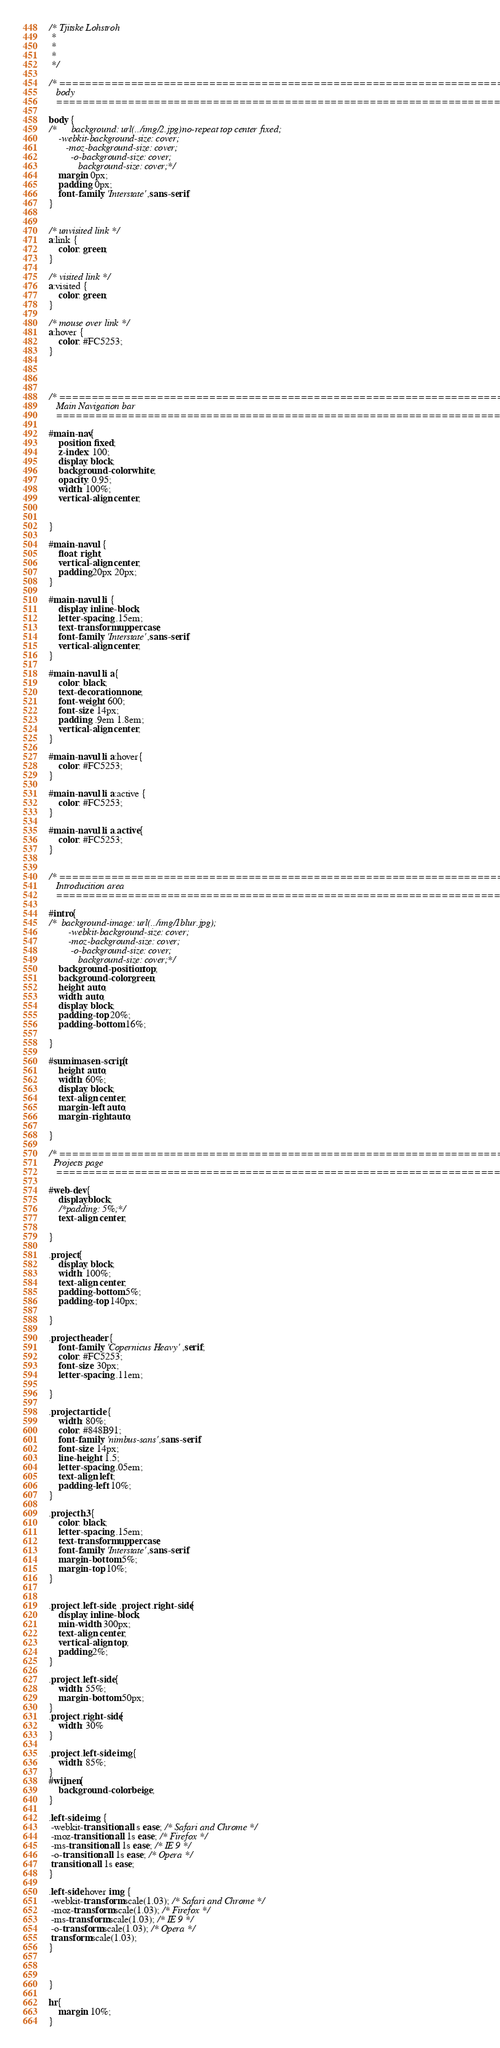Convert code to text. <code><loc_0><loc_0><loc_500><loc_500><_CSS_>/* Tjitske Lohstroh
 * 
 * 
 * 
 */

/* ==========================================================================
   body
   ========================================================================== */

body {
/*   	background: url(../img/2.jpg)no-repeat top center fixed;
	-webkit-background-size: cover;
	   -moz-background-size: cover;
	     -o-background-size: cover;
	        background-size: cover;*/
	margin: 0px;
	padding: 0px;
	font-family: 'Interstate',sans-serif;
}


/* unvisited link */
a:link {
    color: green;
}

/* visited link */
a:visited {
    color: green;
}

/* mouse over link */
a:hover {
    color: #FC5253;
}




/* ==========================================================================
   Main Navigation bar
   ========================================================================== */

#main-nav{
	position: fixed;
	z-index: 100;
   	display: block;
   	background-color: white;
   	opacity: 0.95;
   	width: 100%;
   	vertical-align: center;

   	
}

#main-nav ul {
	float: right;
	vertical-align: center;
	padding:20px 20px;
}

#main-nav ul li {
	display: inline-block;
	letter-spacing: .15em;
	text-transform: uppercase;
	font-family: 'Interstate',sans-serif;
	vertical-align: center;
}

#main-nav ul li a{
	color: black;
	text-decoration: none;
    font-weight: 600;
    font-size: 14px;
    padding: .9em 1.8em;
  	vertical-align: center;
}

#main-nav ul li a:hover{
	color: #FC5253;
}

#main-nav ul li a:active {
    color: #FC5253;
}

#main-nav ul li a.active{
	color: #FC5253;
}


/* ==========================================================================
   Introducition area
   ========================================================================== */

#intro{
/*	background-image: url(../img/1blur.jpg);
		-webkit-background-size: cover;
	    -moz-background-size: cover;
	     -o-background-size: cover;
	        background-size: cover;*/
	background-position: top;
	background-color: green;
	height: auto;
	width: auto;
	display: block;
	padding-top: 20%;
	padding-bottom: 16%;

}

#sumimasen-script{
	height: auto;
	width: 60%;
	display: block;
	text-align: center;
	margin-left: auto;
	margin-right: auto;

}

/* ==========================================================================
  Projects page
   ========================================================================== */

#web-dev{
	display:block;
	/*padding: 5%;*/
	text-align: center;

}

.project{
	display: block;
	width: 100%;
	text-align: center;
	padding-bottom: 5%;
	padding-top: 140px;

}

.project header {
	font-family: 'Copernicus Heavy',serif;
	color: #FC5253;
	font-size: 30px;
	letter-spacing: .11em;
	
}

.project article {
	width: 80%;
	color: #848B91;
	font-family: 'nimbus-sans',sans-serif;
	font-size: 14px;
	line-height: 1.5;
	letter-spacing: .05em;
	text-align: left;
	padding-left: 10%;
}

.project h3{
	color: black;
	letter-spacing: .15em;
	text-transform: uppercase;
	font-family: 'Interstate',sans-serif;
	margin-bottom: 5%;
	margin-top: 10%;
}


.project .left-side, .project .right-side{
	display: inline-block;
	min-width: 300px;
	text-align: center;
	vertical-align: top;
	padding:2%;
}

.project .left-side{
	width: 55%;
	margin-bottom: 50px;
}
.project .right-side{
	width: 30%
}

.project .left-side img{
	width: 85%;
}
#wijnen{
	background-color: beige;
}

.left-side img {
 -webkit-transition: all s ease; /* Safari and Chrome */
 -moz-transition: all 1s ease; /* Firefox */
 -ms-transition: all 1s ease; /* IE 9 */
 -o-transition: all 1s ease; /* Opera */
 transition: all 1s ease;
}

.left-side:hover img {
 -webkit-transform:scale(1.03); /* Safari and Chrome */
 -moz-transform:scale(1.03); /* Firefox */
 -ms-transform:scale(1.03); /* IE 9 */
 -o-transform:scale(1.03); /* Opera */
 transform:scale(1.03);
}



}

hr{
	margin: 10%;
}
</code> 